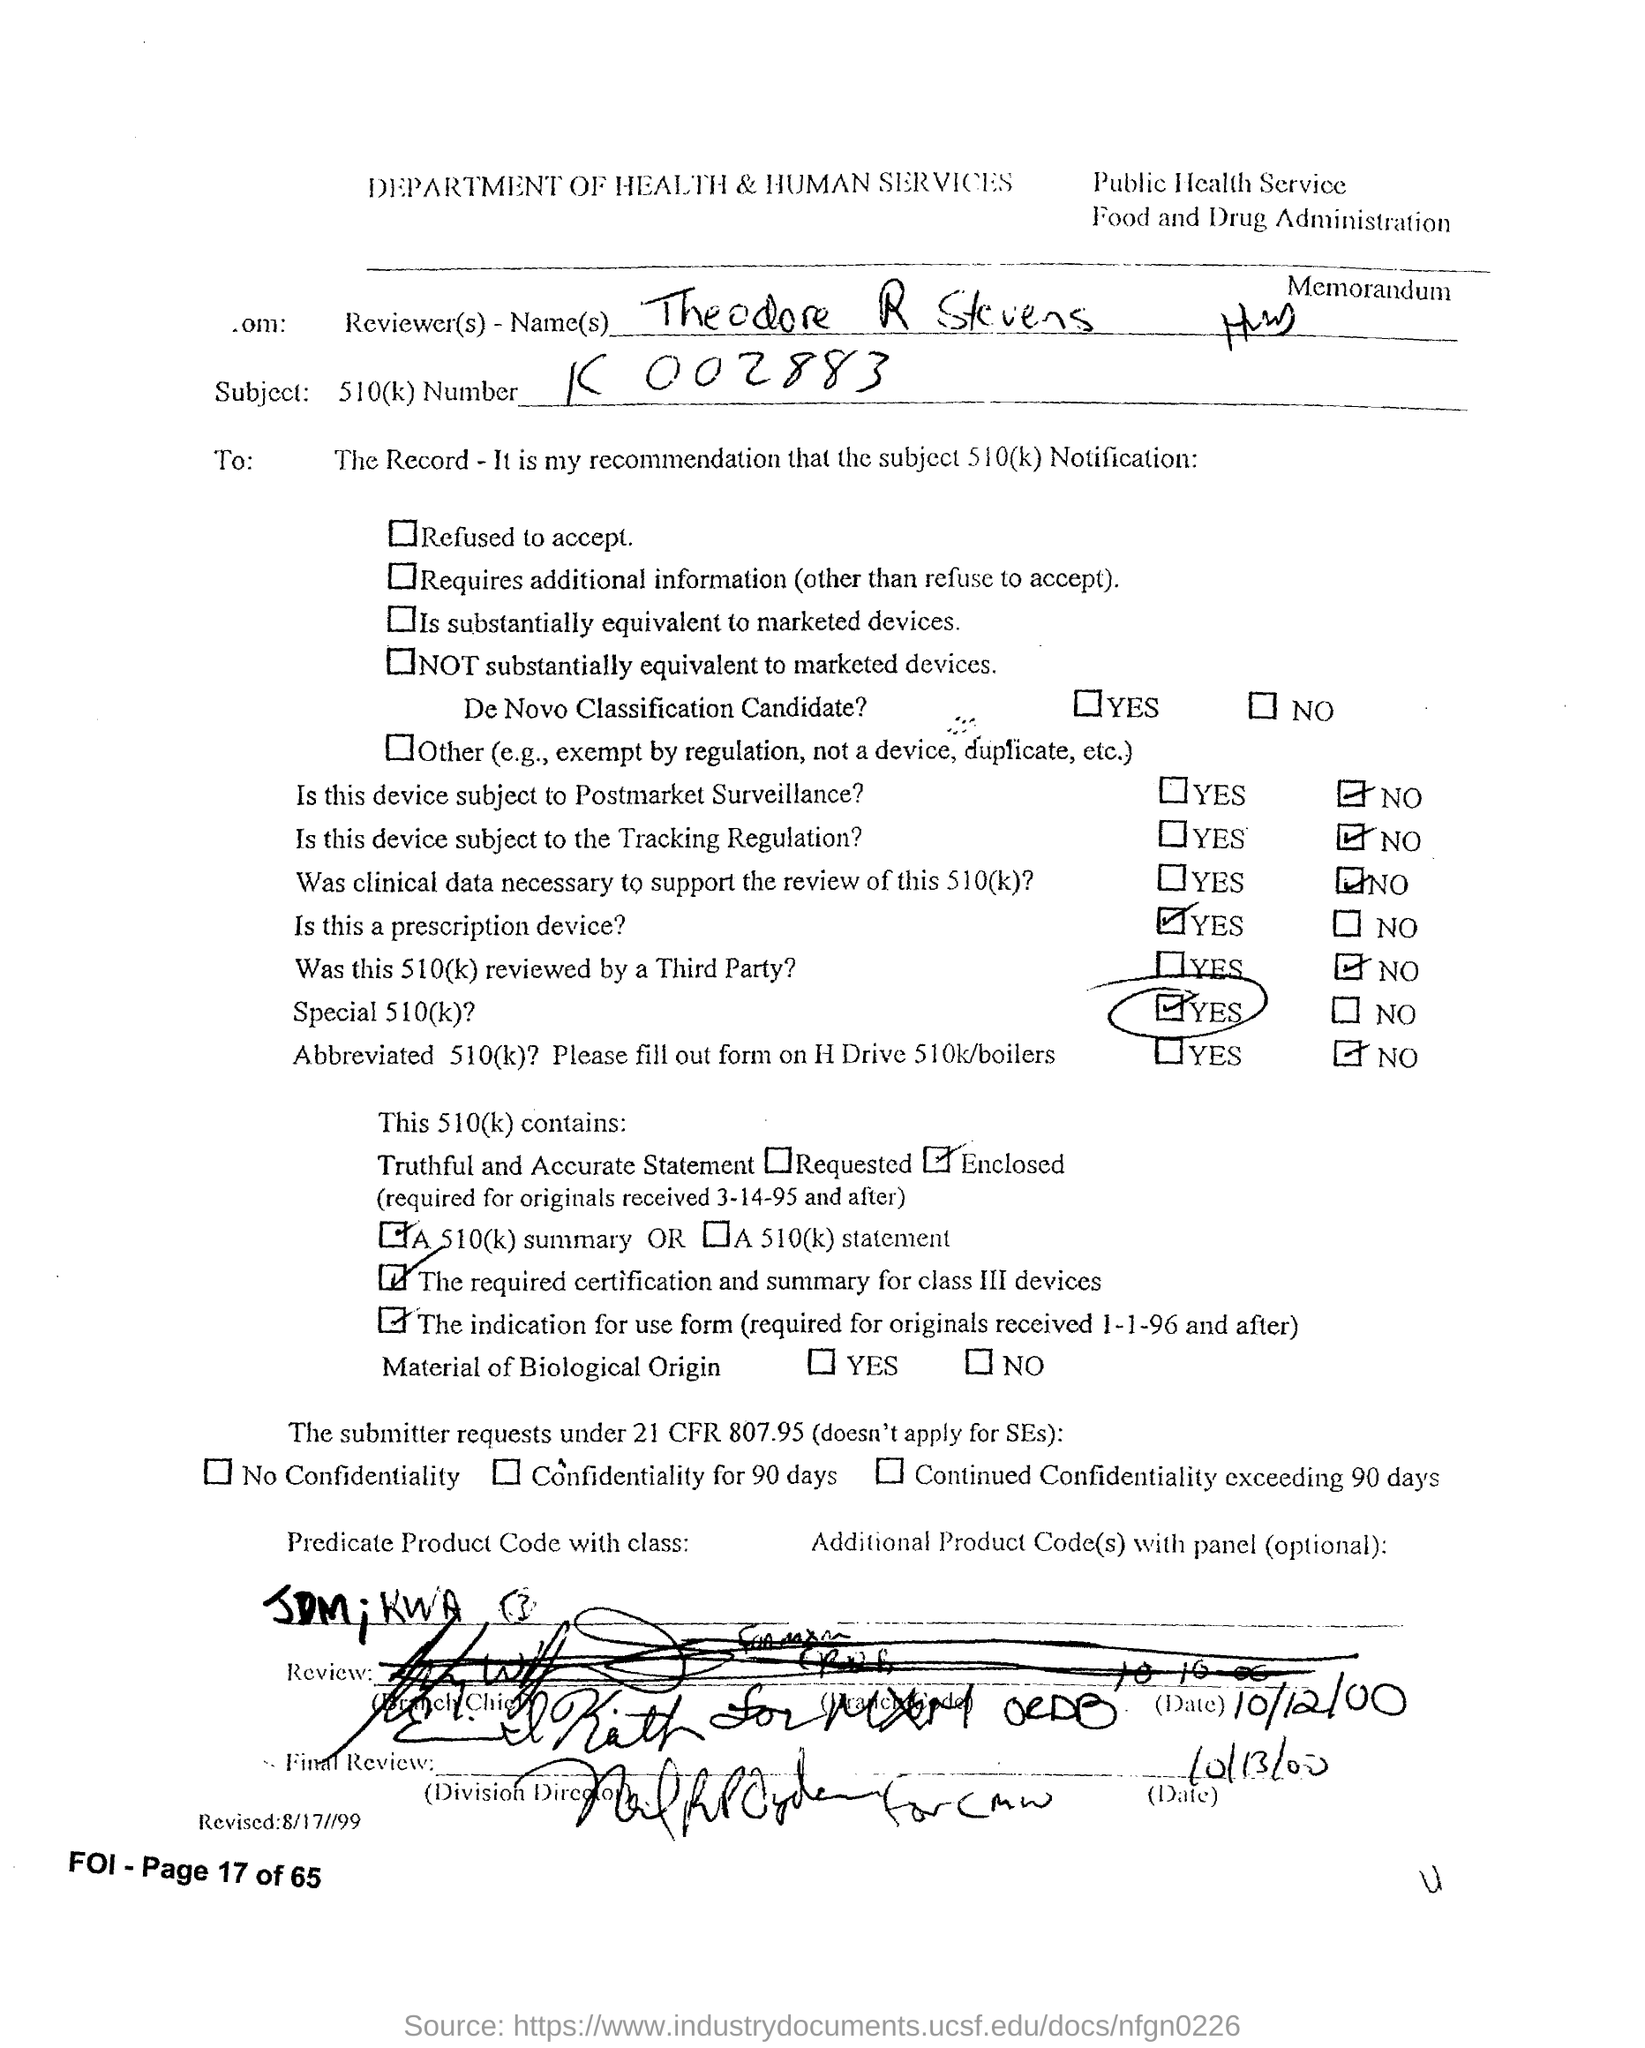Which department is mentioned in the header of the document?
Ensure brevity in your answer.  DEPARTMENT OF HEALTH & HUMAN SERVICES. 